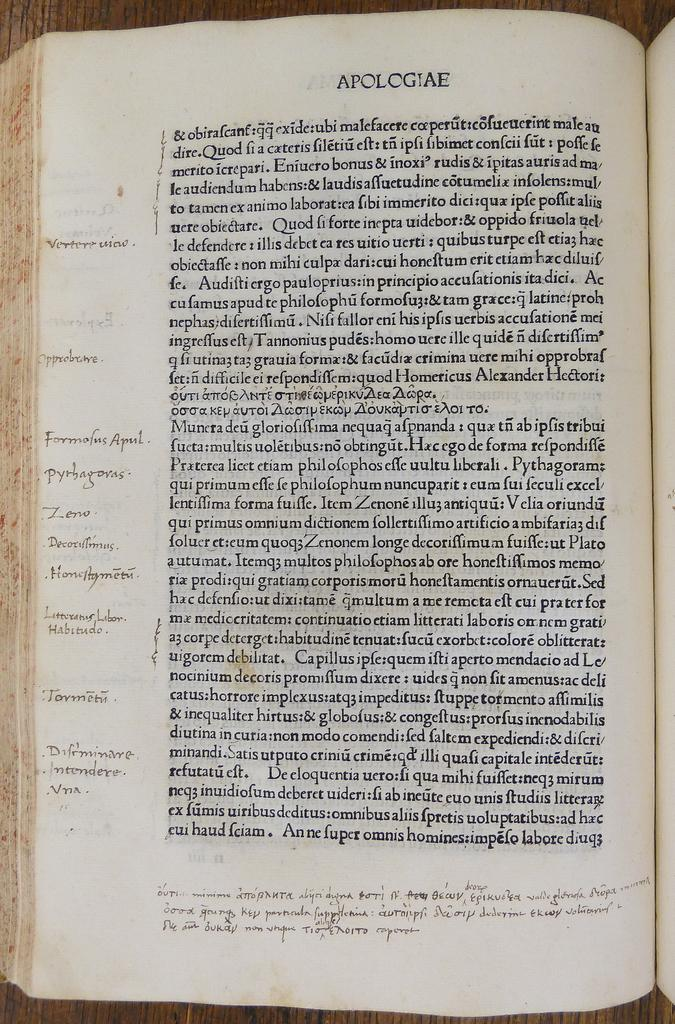<image>
Summarize the visual content of the image. A book is opened to a page which is titled Apologiae. 